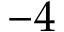Convert formula to latex. <formula><loc_0><loc_0><loc_500><loc_500>- 4</formula> 